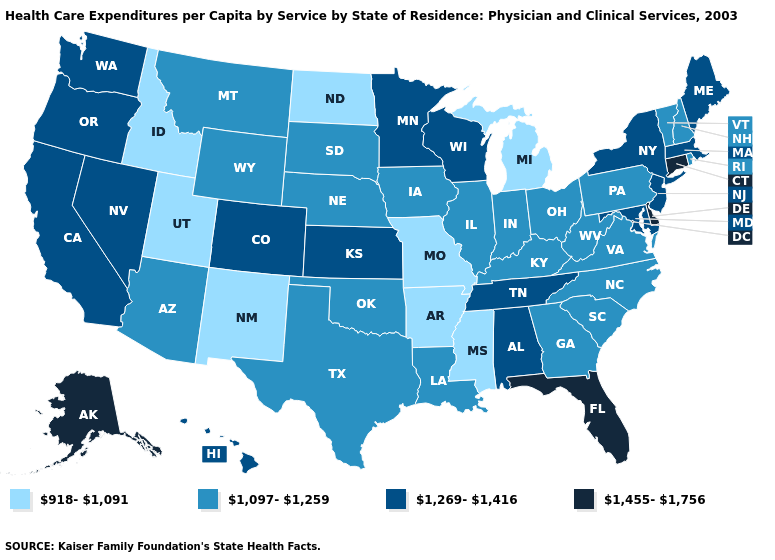What is the highest value in states that border Texas?
Keep it brief. 1,097-1,259. Among the states that border Arizona , which have the lowest value?
Be succinct. New Mexico, Utah. Which states have the highest value in the USA?
Write a very short answer. Alaska, Connecticut, Delaware, Florida. Does Iowa have the lowest value in the USA?
Give a very brief answer. No. What is the value of Montana?
Concise answer only. 1,097-1,259. Does Hawaii have a higher value than Colorado?
Write a very short answer. No. Is the legend a continuous bar?
Concise answer only. No. How many symbols are there in the legend?
Quick response, please. 4. What is the value of Kentucky?
Be succinct. 1,097-1,259. Name the states that have a value in the range 918-1,091?
Answer briefly. Arkansas, Idaho, Michigan, Mississippi, Missouri, New Mexico, North Dakota, Utah. Name the states that have a value in the range 1,269-1,416?
Be succinct. Alabama, California, Colorado, Hawaii, Kansas, Maine, Maryland, Massachusetts, Minnesota, Nevada, New Jersey, New York, Oregon, Tennessee, Washington, Wisconsin. Does California have the highest value in the USA?
Keep it brief. No. Among the states that border Tennessee , which have the highest value?
Answer briefly. Alabama. Which states hav the highest value in the West?
Short answer required. Alaska. 